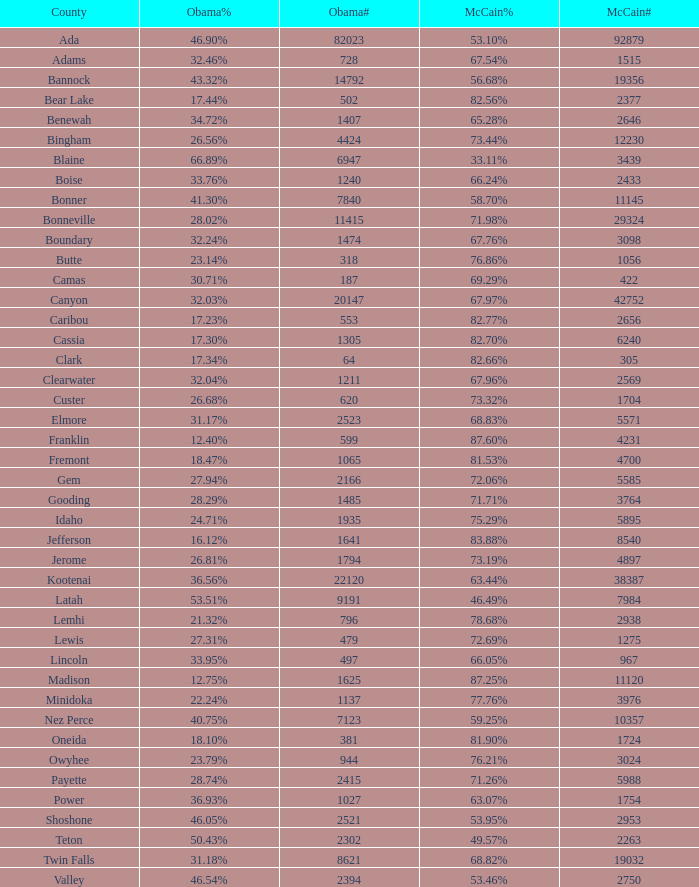What was obama's vote percentage in gem county? 27.94%. 